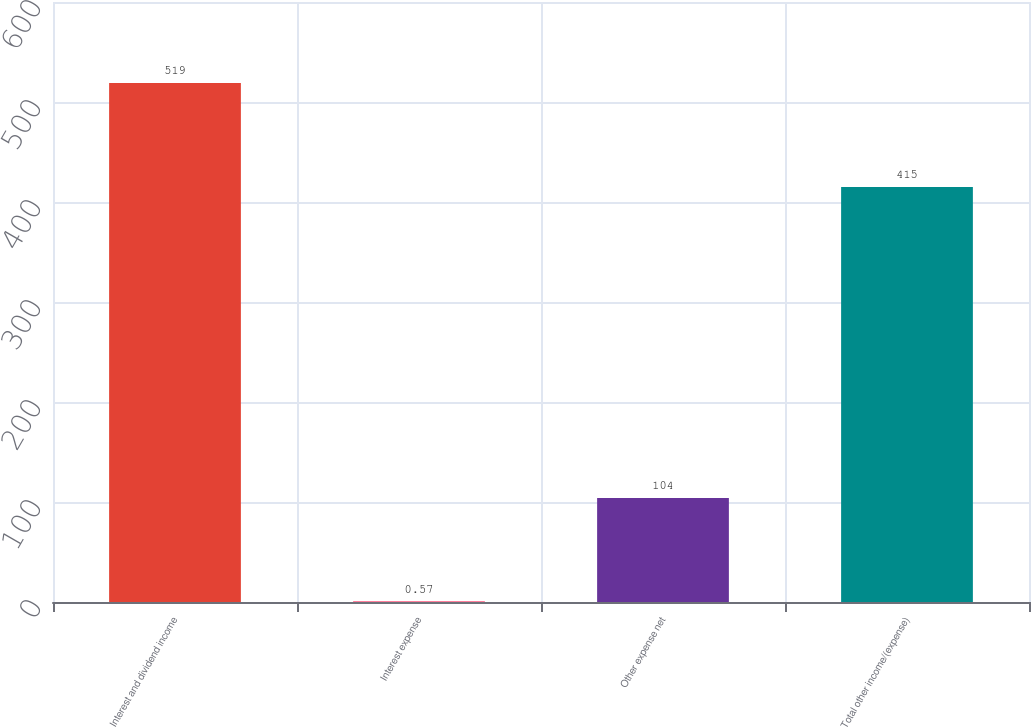Convert chart to OTSL. <chart><loc_0><loc_0><loc_500><loc_500><bar_chart><fcel>Interest and dividend income<fcel>Interest expense<fcel>Other expense net<fcel>Total other income/(expense)<nl><fcel>519<fcel>0.57<fcel>104<fcel>415<nl></chart> 